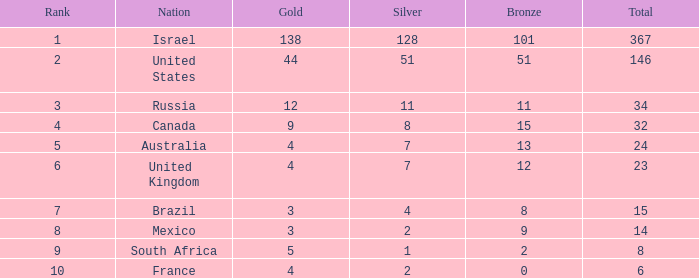Can you parse all the data within this table? {'header': ['Rank', 'Nation', 'Gold', 'Silver', 'Bronze', 'Total'], 'rows': [['1', 'Israel', '138', '128', '101', '367'], ['2', 'United States', '44', '51', '51', '146'], ['3', 'Russia', '12', '11', '11', '34'], ['4', 'Canada', '9', '8', '15', '32'], ['5', 'Australia', '4', '7', '13', '24'], ['6', 'United Kingdom', '4', '7', '12', '23'], ['7', 'Brazil', '3', '4', '8', '15'], ['8', 'Mexico', '3', '2', '9', '14'], ['9', 'South Africa', '5', '1', '2', '8'], ['10', 'France', '4', '2', '0', '6']]} What is the maximum number of silvers for a country with fewer than 12 golds and a total less than 8? 2.0. 